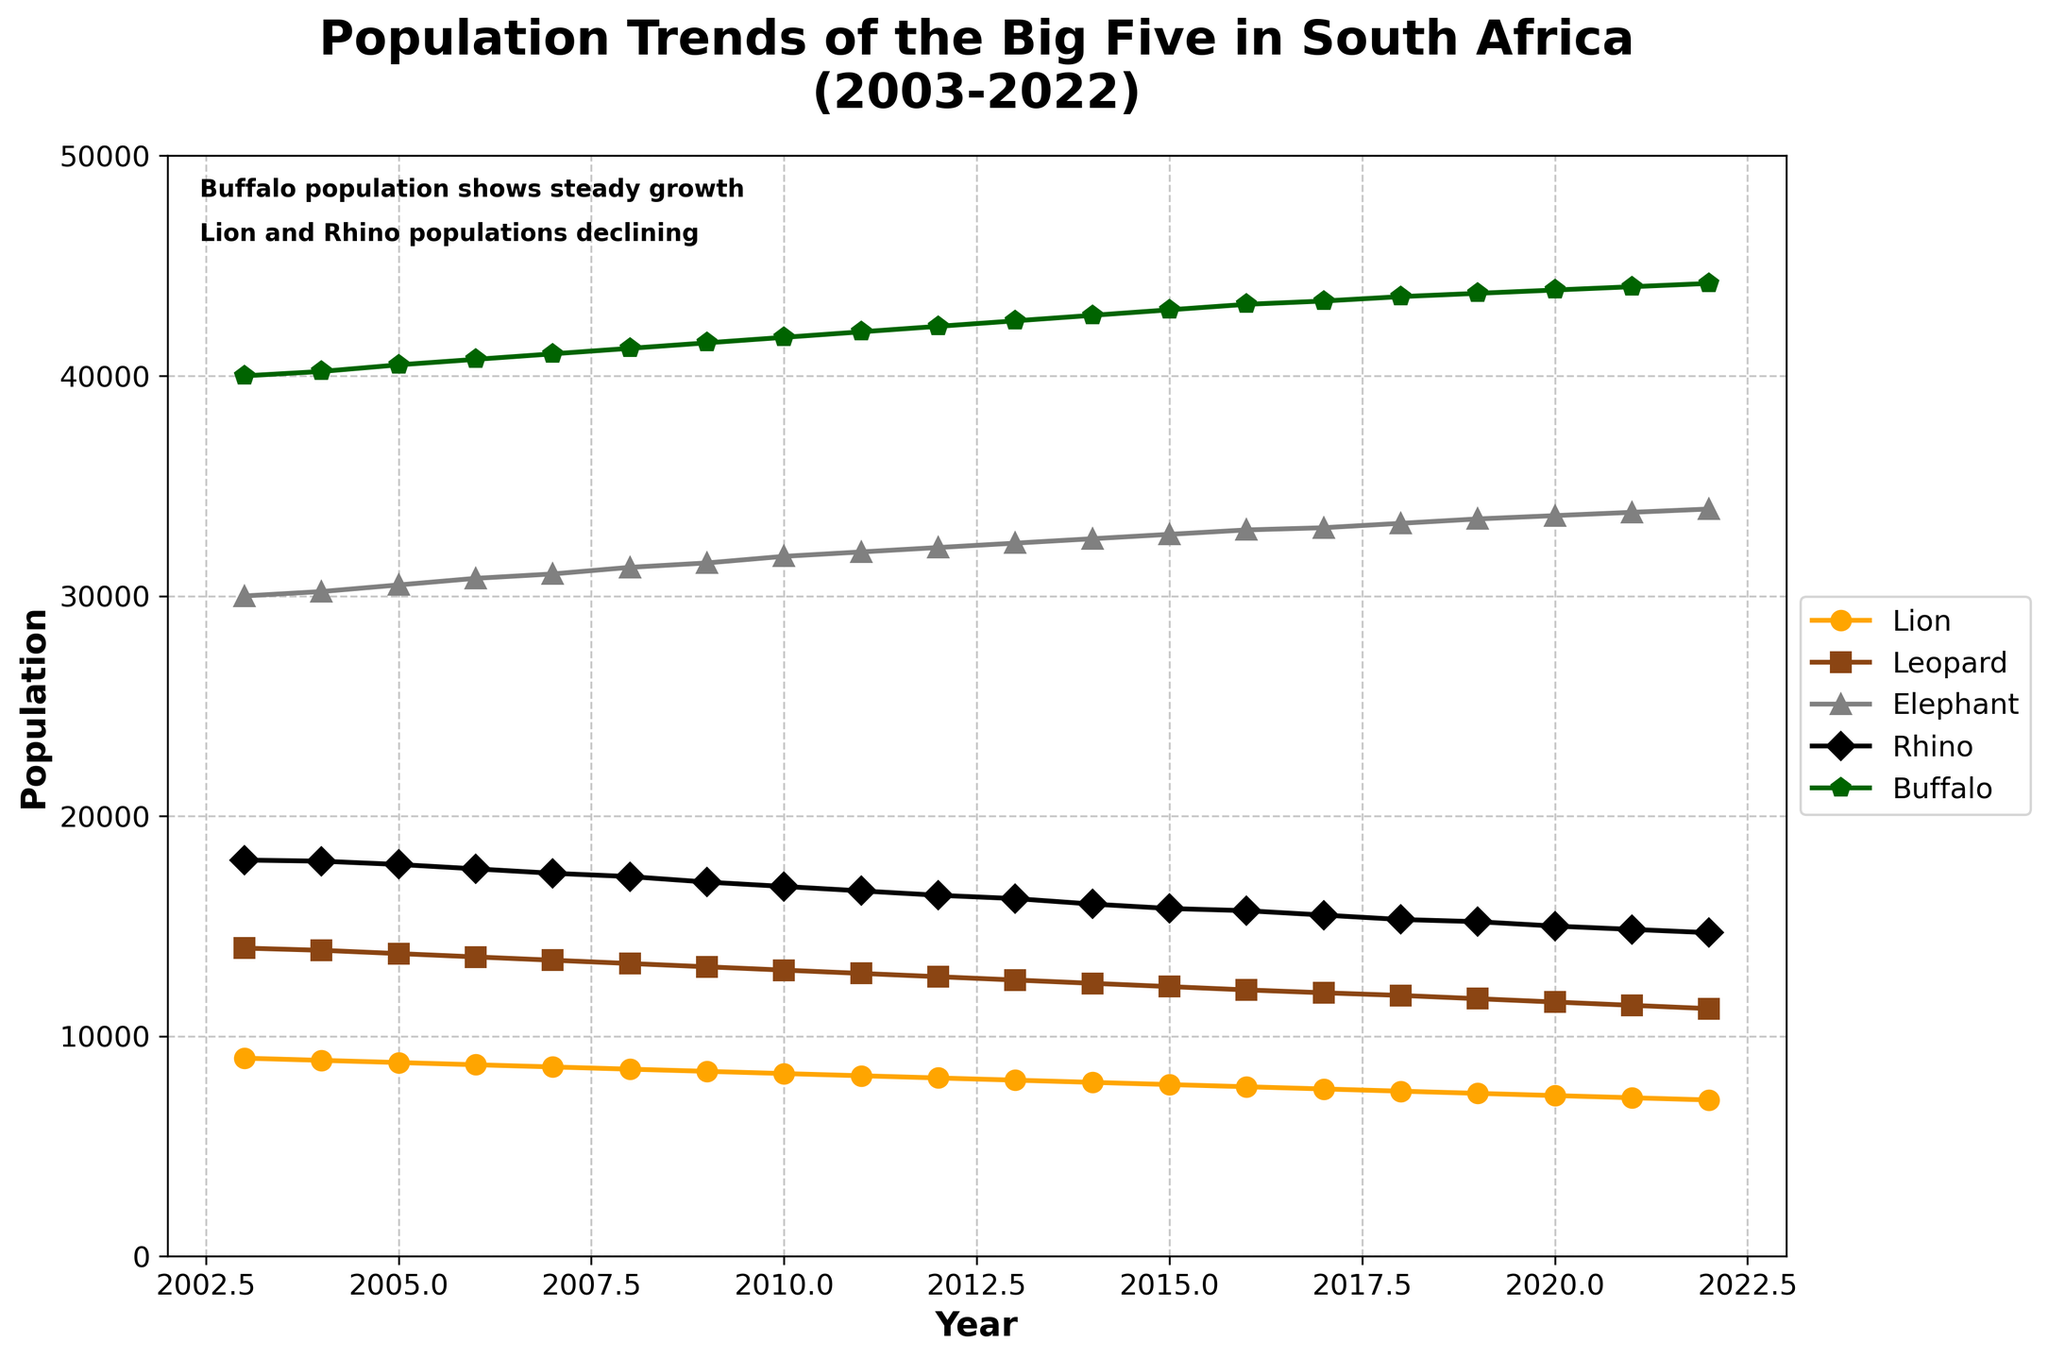What is the overall trend in the lion population from 2003 to 2022? The lion population starts at 9000 in 2003 and gradually decreases to 7100 in 2022. This indicates a downward trend over the two decades.
Answer: Downward What year did the elephant population first reach 30,000? The elephant population first reached 30,000 in 2003. By 2004, it slightly increased to 30,200.
Answer: 2003 Which animal's population shows the most consistent growth over the time period? By analyzing the figure, the buffalo population shows the most consistent growth, increasing steadily from 40,000 in 2003 to 44,200 in 2022.
Answer: Buffalo Between 2010 and 2020, which animal had the sharpest decline in population? By comparing the population values between 2010 and 2020, the lion population declines sharply from 8300 to 7300, more than any other animal within that period.
Answer: Lion What is the difference between the rhino population in 2010 and 2022? The rhino population was 16,800 in 2010 and 14,700 in 2022. The difference is 16,800 - 14,700 = 2,100.
Answer: 2,100 How many animals in total are represented in the year 2015? Summing up the populations of all five animals in 2015: Lion (7800) + Leopard (12250) + Elephant (32800) + Rhino (15800) + Buffalo (43000) = 11,064.
Answer: 109,650 In which year did the leopard population drop below 12,000? The leopard population first drops below 12,000 in 2016, reaching 11,970.
Answer: 2016 Which two animals have crossing population trends? The buffalo population shows a rising trend while the lion and rhino populations show a declining trend, creating a crossing effect where the lines may intersect visually over time. However, the most distinctly crossing trends are not directly apparent in the plot as populations don't exactly cross each other literal amount-wise It is more a general observation.
Answer: Lion and Buffalo What is the approximate average population of the leopard over the two decades? To find the average, sum up all the population values for the leopard and divide by the number of years: (14000 + 13900 + ... + 11250)/20.
Answer: ~12767.5 Which animal had the smallest population change from 2003 to 2022? The comparison of the population difference for each animal from 2003 to 2022 shows that the leopard’s population changed from 14000 to 11250, a difference of 2750, which is smaller than other animals' population changes.
Answer: Leopard 